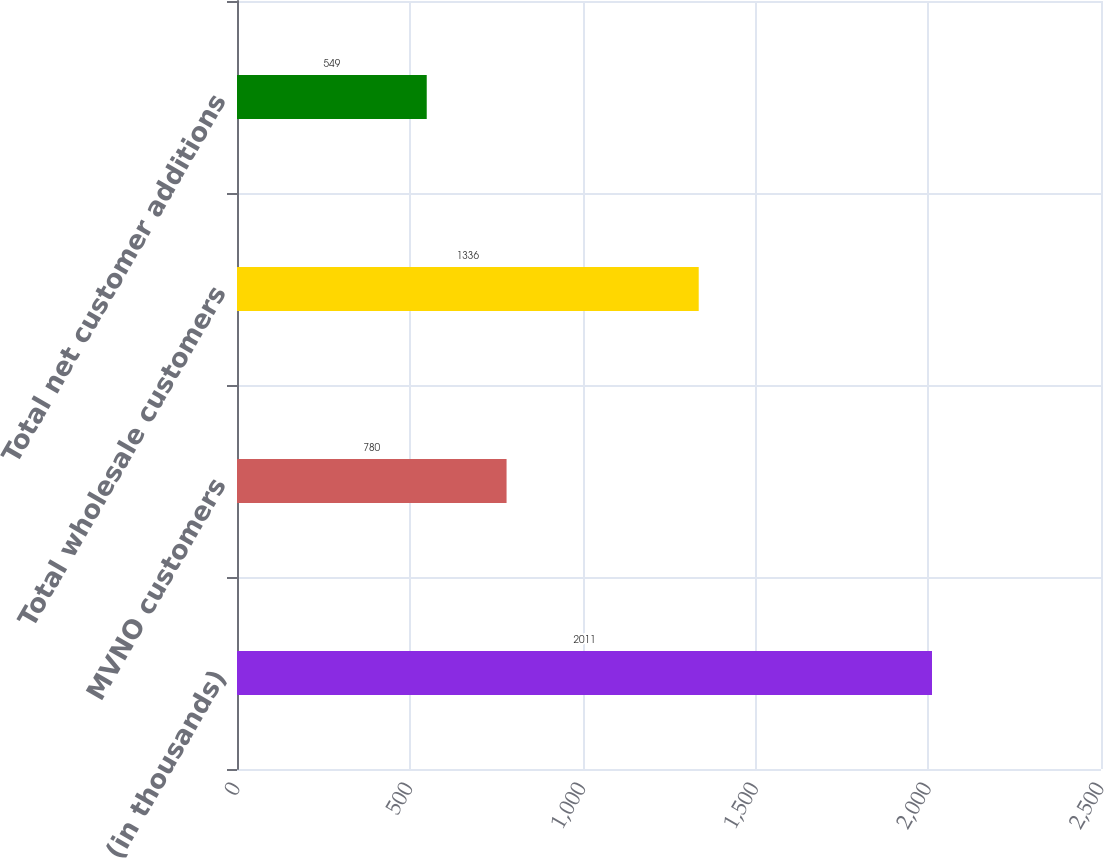Convert chart. <chart><loc_0><loc_0><loc_500><loc_500><bar_chart><fcel>(in thousands)<fcel>MVNO customers<fcel>Total wholesale customers<fcel>Total net customer additions<nl><fcel>2011<fcel>780<fcel>1336<fcel>549<nl></chart> 